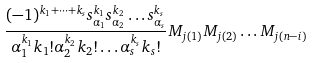<formula> <loc_0><loc_0><loc_500><loc_500>\frac { ( - 1 ) ^ { k _ { 1 } + \dots + k _ { s } } s _ { \alpha _ { 1 } } ^ { k _ { 1 } } s _ { \alpha _ { 2 } } ^ { k _ { 2 } } \dots s _ { \alpha _ { s } } ^ { k _ { s } } } { \alpha _ { 1 } ^ { k _ { 1 } } k _ { 1 } ! \alpha _ { 2 } ^ { k _ { 2 } } k _ { 2 } ! \dots \alpha _ { s } ^ { k _ { s } } k _ { s } ! } M _ { j ( 1 ) } M _ { j ( 2 ) } \dots M _ { j ( n - i ) }</formula> 